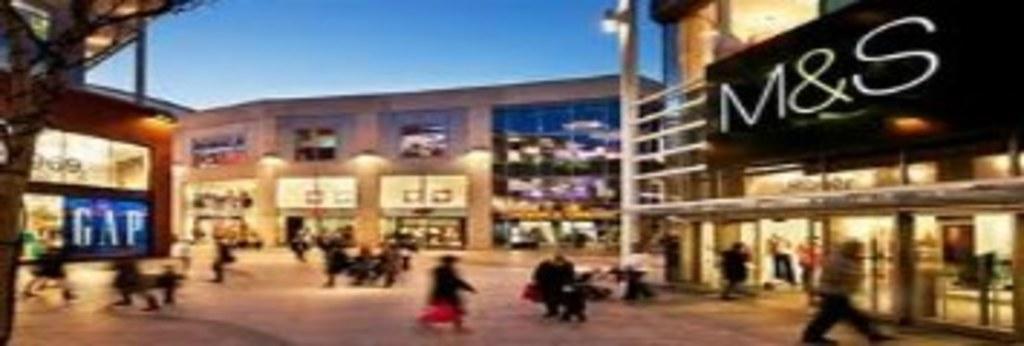Could you give a brief overview of what you see in this image? In this image there are buildings. On the right side, we can see a board with text M&S. There are people walking. On the left side there is a tree. There is a sky. 